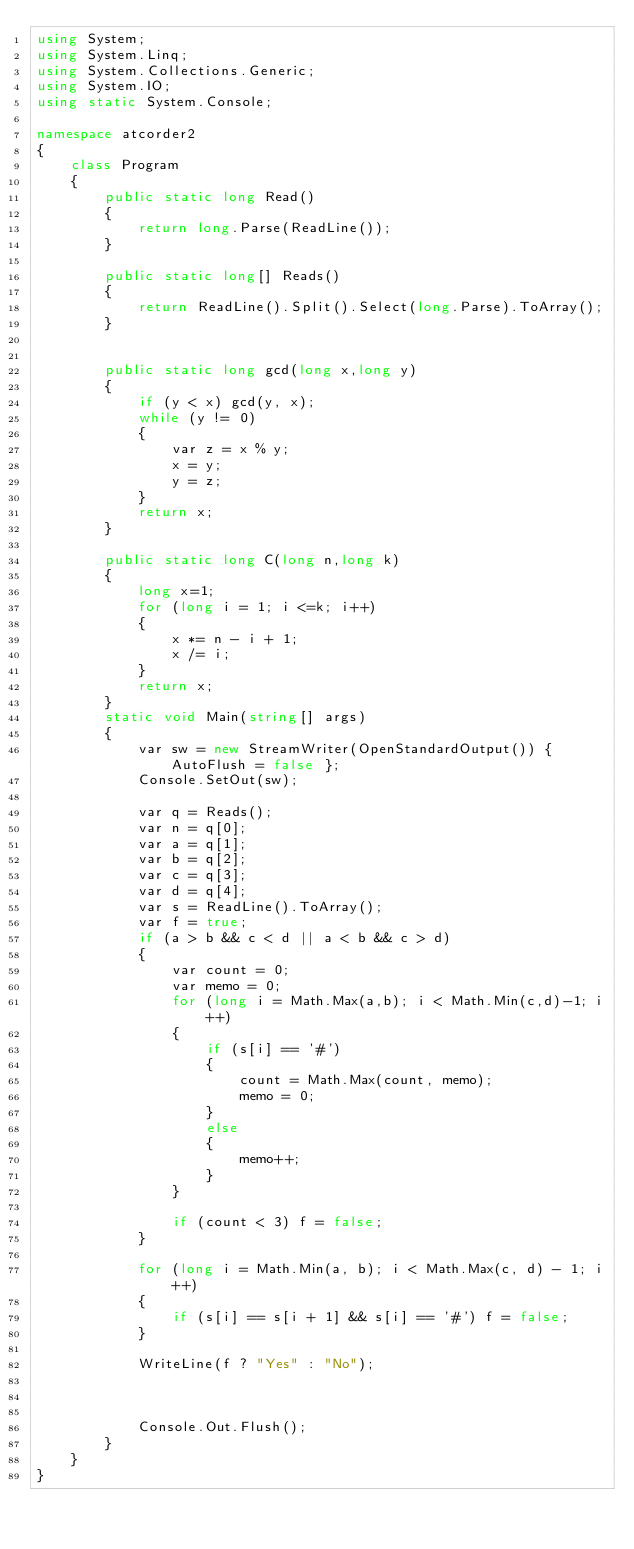<code> <loc_0><loc_0><loc_500><loc_500><_C#_>using System;
using System.Linq;
using System.Collections.Generic;
using System.IO;
using static System.Console;

namespace atcorder2
{
    class Program
    {
        public static long Read()
        {
            return long.Parse(ReadLine());
        }

        public static long[] Reads()
        {
            return ReadLine().Split().Select(long.Parse).ToArray();
        }


        public static long gcd(long x,long y)
        {
            if (y < x) gcd(y, x);
            while (y != 0)
            {
                var z = x % y;
                x = y;
                y = z;
            }
            return x;
        }

        public static long C(long n,long k)
        {
            long x=1;
            for (long i = 1; i <=k; i++)
            {
                x *= n - i + 1;
                x /= i;
            }
            return x;
        }
        static void Main(string[] args)
        {
            var sw = new StreamWriter(OpenStandardOutput()) { AutoFlush = false };
            Console.SetOut(sw);

            var q = Reads();
            var n = q[0];
            var a = q[1];
            var b = q[2];
            var c = q[3];
            var d = q[4];
            var s = ReadLine().ToArray();
            var f = true;
            if (a > b && c < d || a < b && c > d)
            {
                var count = 0;
                var memo = 0;
                for (long i = Math.Max(a,b); i < Math.Min(c,d)-1; i++)
                {
                    if (s[i] == '#')
                    {
                        count = Math.Max(count, memo);
                        memo = 0;
                    }
                    else
                    {
                        memo++;
                    }
                }

                if (count < 3) f = false;
            }

            for (long i = Math.Min(a, b); i < Math.Max(c, d) - 1; i++)
            {
                if (s[i] == s[i + 1] && s[i] == '#') f = false;
            }
            
            WriteLine(f ? "Yes" : "No");
            


            Console.Out.Flush();
        }
    }
}
</code> 